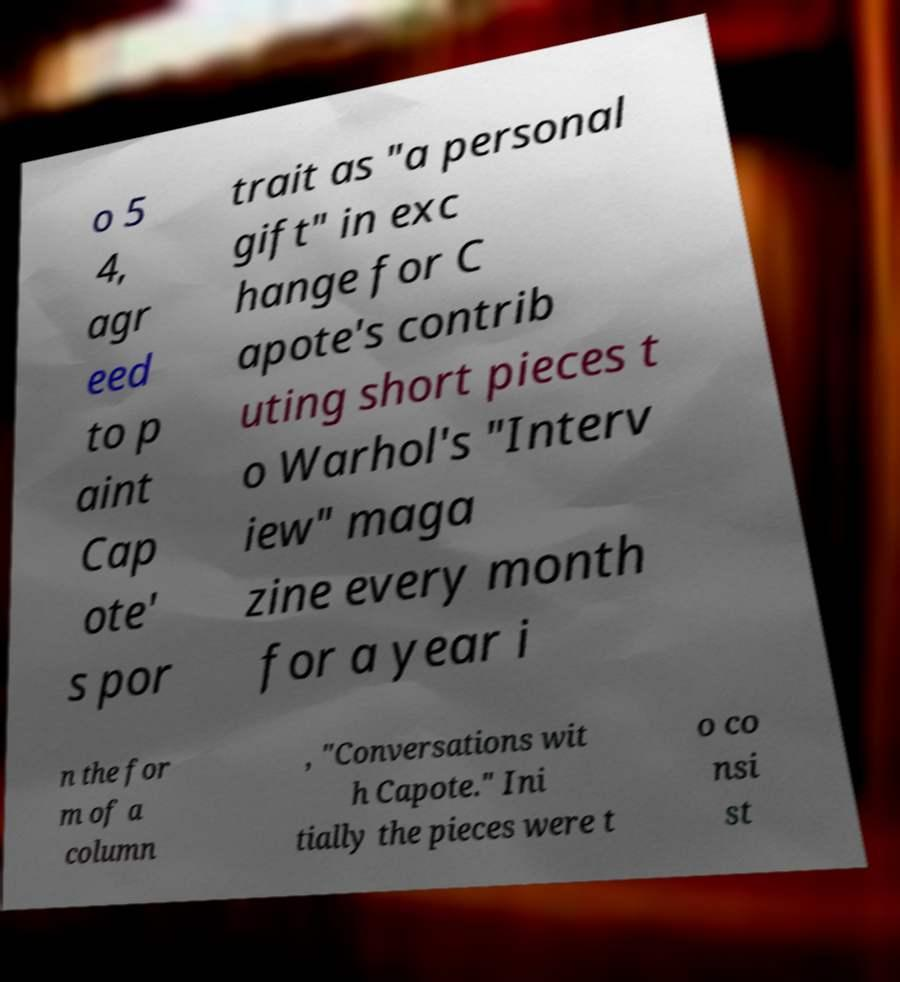Could you assist in decoding the text presented in this image and type it out clearly? o 5 4, agr eed to p aint Cap ote' s por trait as "a personal gift" in exc hange for C apote's contrib uting short pieces t o Warhol's "Interv iew" maga zine every month for a year i n the for m of a column , "Conversations wit h Capote." Ini tially the pieces were t o co nsi st 